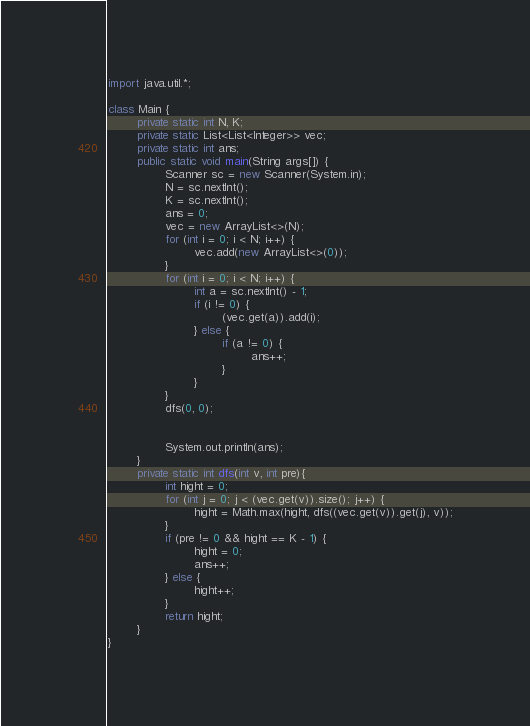Convert code to text. <code><loc_0><loc_0><loc_500><loc_500><_Java_>import java.util.*;

class Main {
        private static int N, K;
        private static List<List<Integer>> vec;
        private static int ans;
        public static void main(String args[]) {
                Scanner sc = new Scanner(System.in);
                N = sc.nextInt();
                K = sc.nextInt();
                ans = 0;
                vec = new ArrayList<>(N);
                for (int i = 0; i < N; i++) {
                        vec.add(new ArrayList<>(0));
                }
                for (int i = 0; i < N; i++) {
                        int a = sc.nextInt() - 1;
                        if (i != 0) {
                                (vec.get(a)).add(i);
                        } else {
                                if (a != 0) {
                                        ans++;
                                }
                        }
                }
                dfs(0, 0);


                System.out.println(ans);
        }
        private static int dfs(int v, int pre){
                int hight = 0;
                for (int j = 0; j < (vec.get(v)).size(); j++) {
                        hight = Math.max(hight, dfs((vec.get(v)).get(j), v));
                }
                if (pre != 0 && hight == K - 1) {
                        hight = 0;
                        ans++;
                } else {
                        hight++;
                }
                return hight;
        }
}</code> 